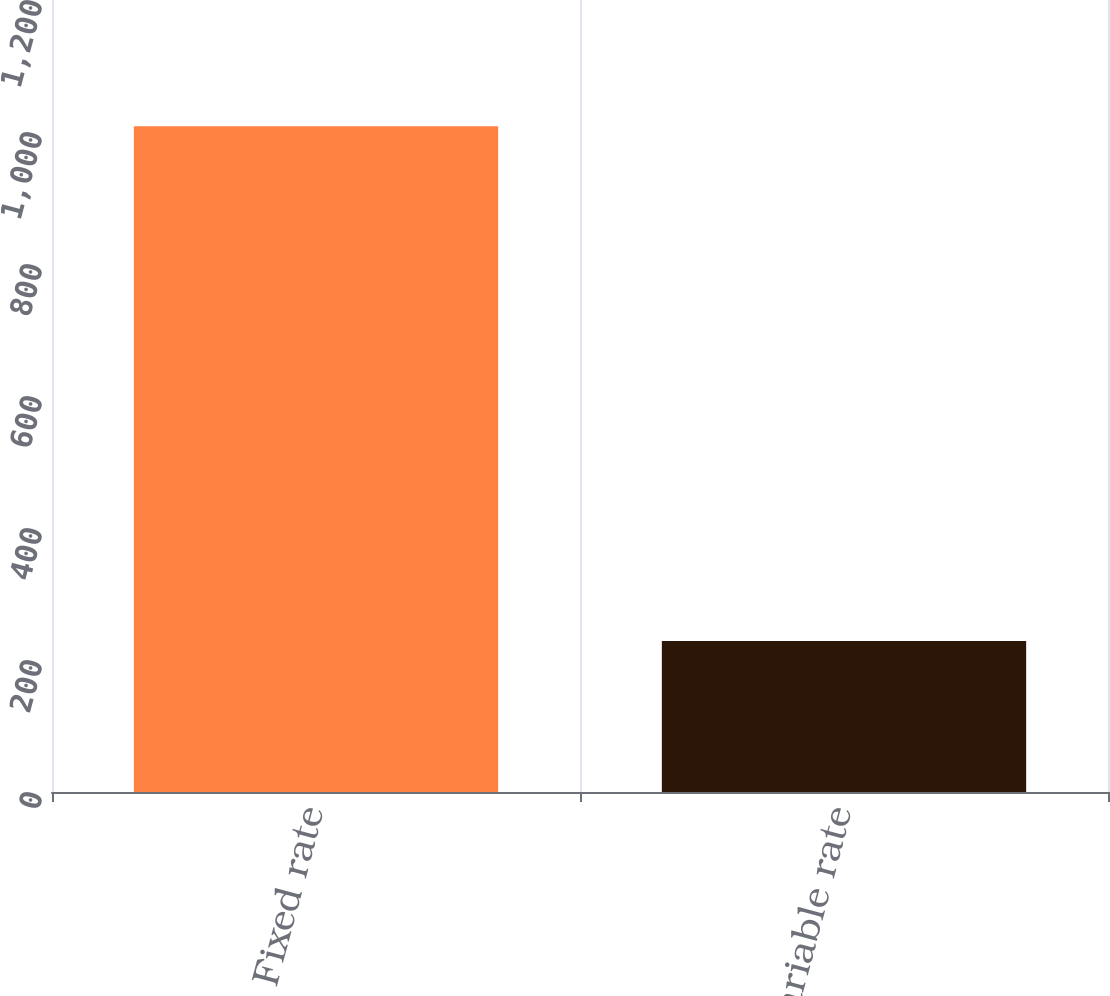<chart> <loc_0><loc_0><loc_500><loc_500><bar_chart><fcel>Fixed rate<fcel>Variable rate<nl><fcel>1008.9<fcel>228.9<nl></chart> 